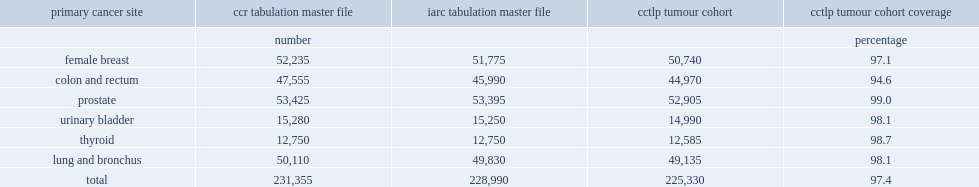What is the percentage of tumours of the same site reported in the ccr tumour file were selected as single primary cancer tumours? 0.973958. 